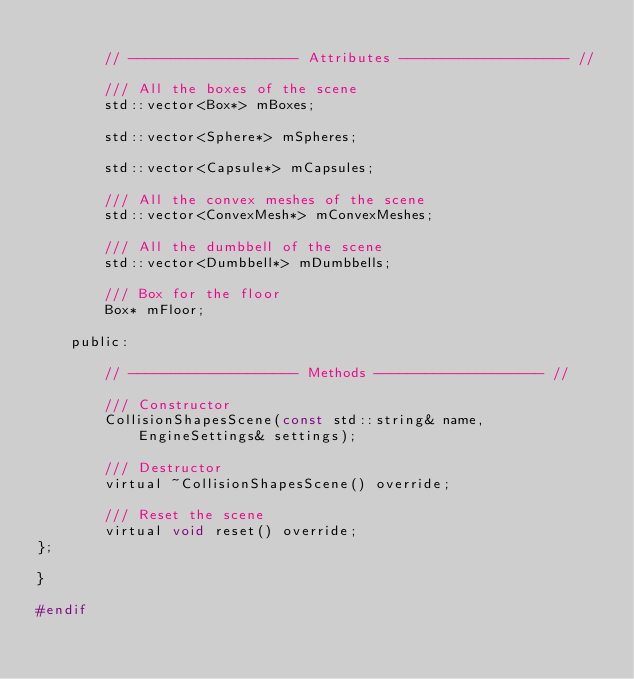<code> <loc_0><loc_0><loc_500><loc_500><_C_>
        // -------------------- Attributes -------------------- //

        /// All the boxes of the scene
        std::vector<Box*> mBoxes;

        std::vector<Sphere*> mSpheres;

        std::vector<Capsule*> mCapsules;

        /// All the convex meshes of the scene
        std::vector<ConvexMesh*> mConvexMeshes;

        /// All the dumbbell of the scene
        std::vector<Dumbbell*> mDumbbells;

        /// Box for the floor
        Box* mFloor;

    public:

        // -------------------- Methods -------------------- //

        /// Constructor
        CollisionShapesScene(const std::string& name, EngineSettings& settings);

        /// Destructor
        virtual ~CollisionShapesScene() override;

        /// Reset the scene
        virtual void reset() override;
};

}

#endif
</code> 